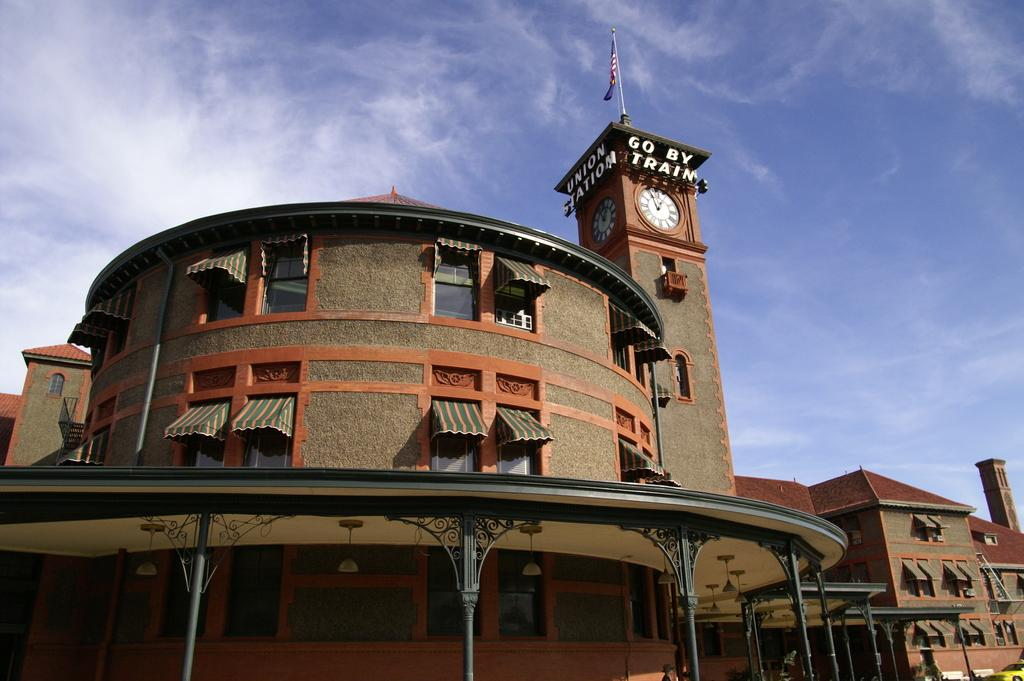What is located in the center of the image? There are buildings in the center of the image. What is visible at the top of the image? The sky is visible at the top of the image. Where is the goat grazing on cabbage in the image? There is no goat or cabbage present in the image; it only features buildings and the sky. 